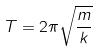<formula> <loc_0><loc_0><loc_500><loc_500>T = 2 \pi \sqrt { \frac { m } { k } }</formula> 